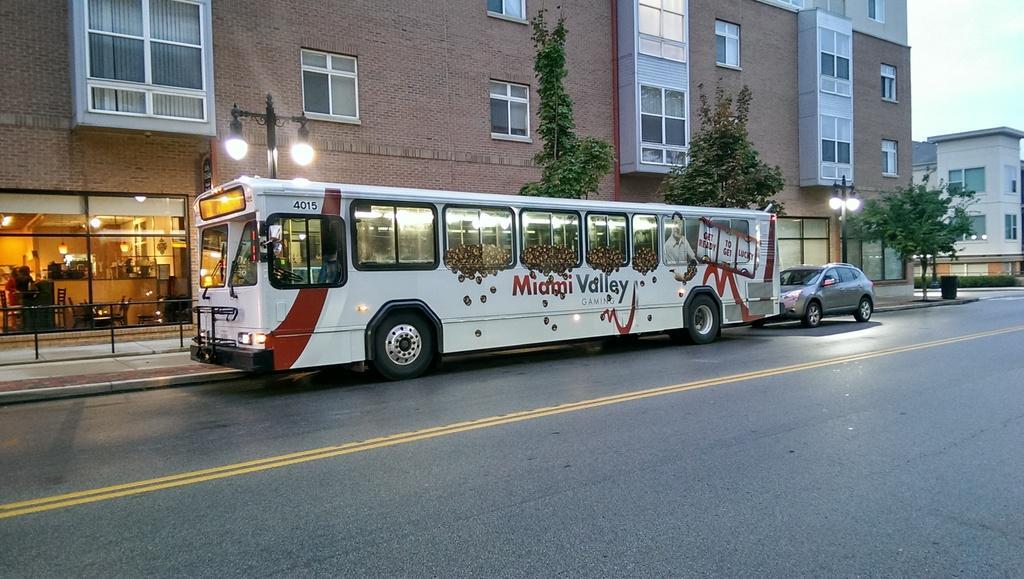Describe this image in one or two sentences. This image is taken outdoors. At the bottom of the image there is a road. In the middle of the image a bus and a car are parked on the road. In the background there are a few buildings with walls, windows, window blinds and doors. There are a few trees and street lights. At the top of the image there is a sky with clouds. 